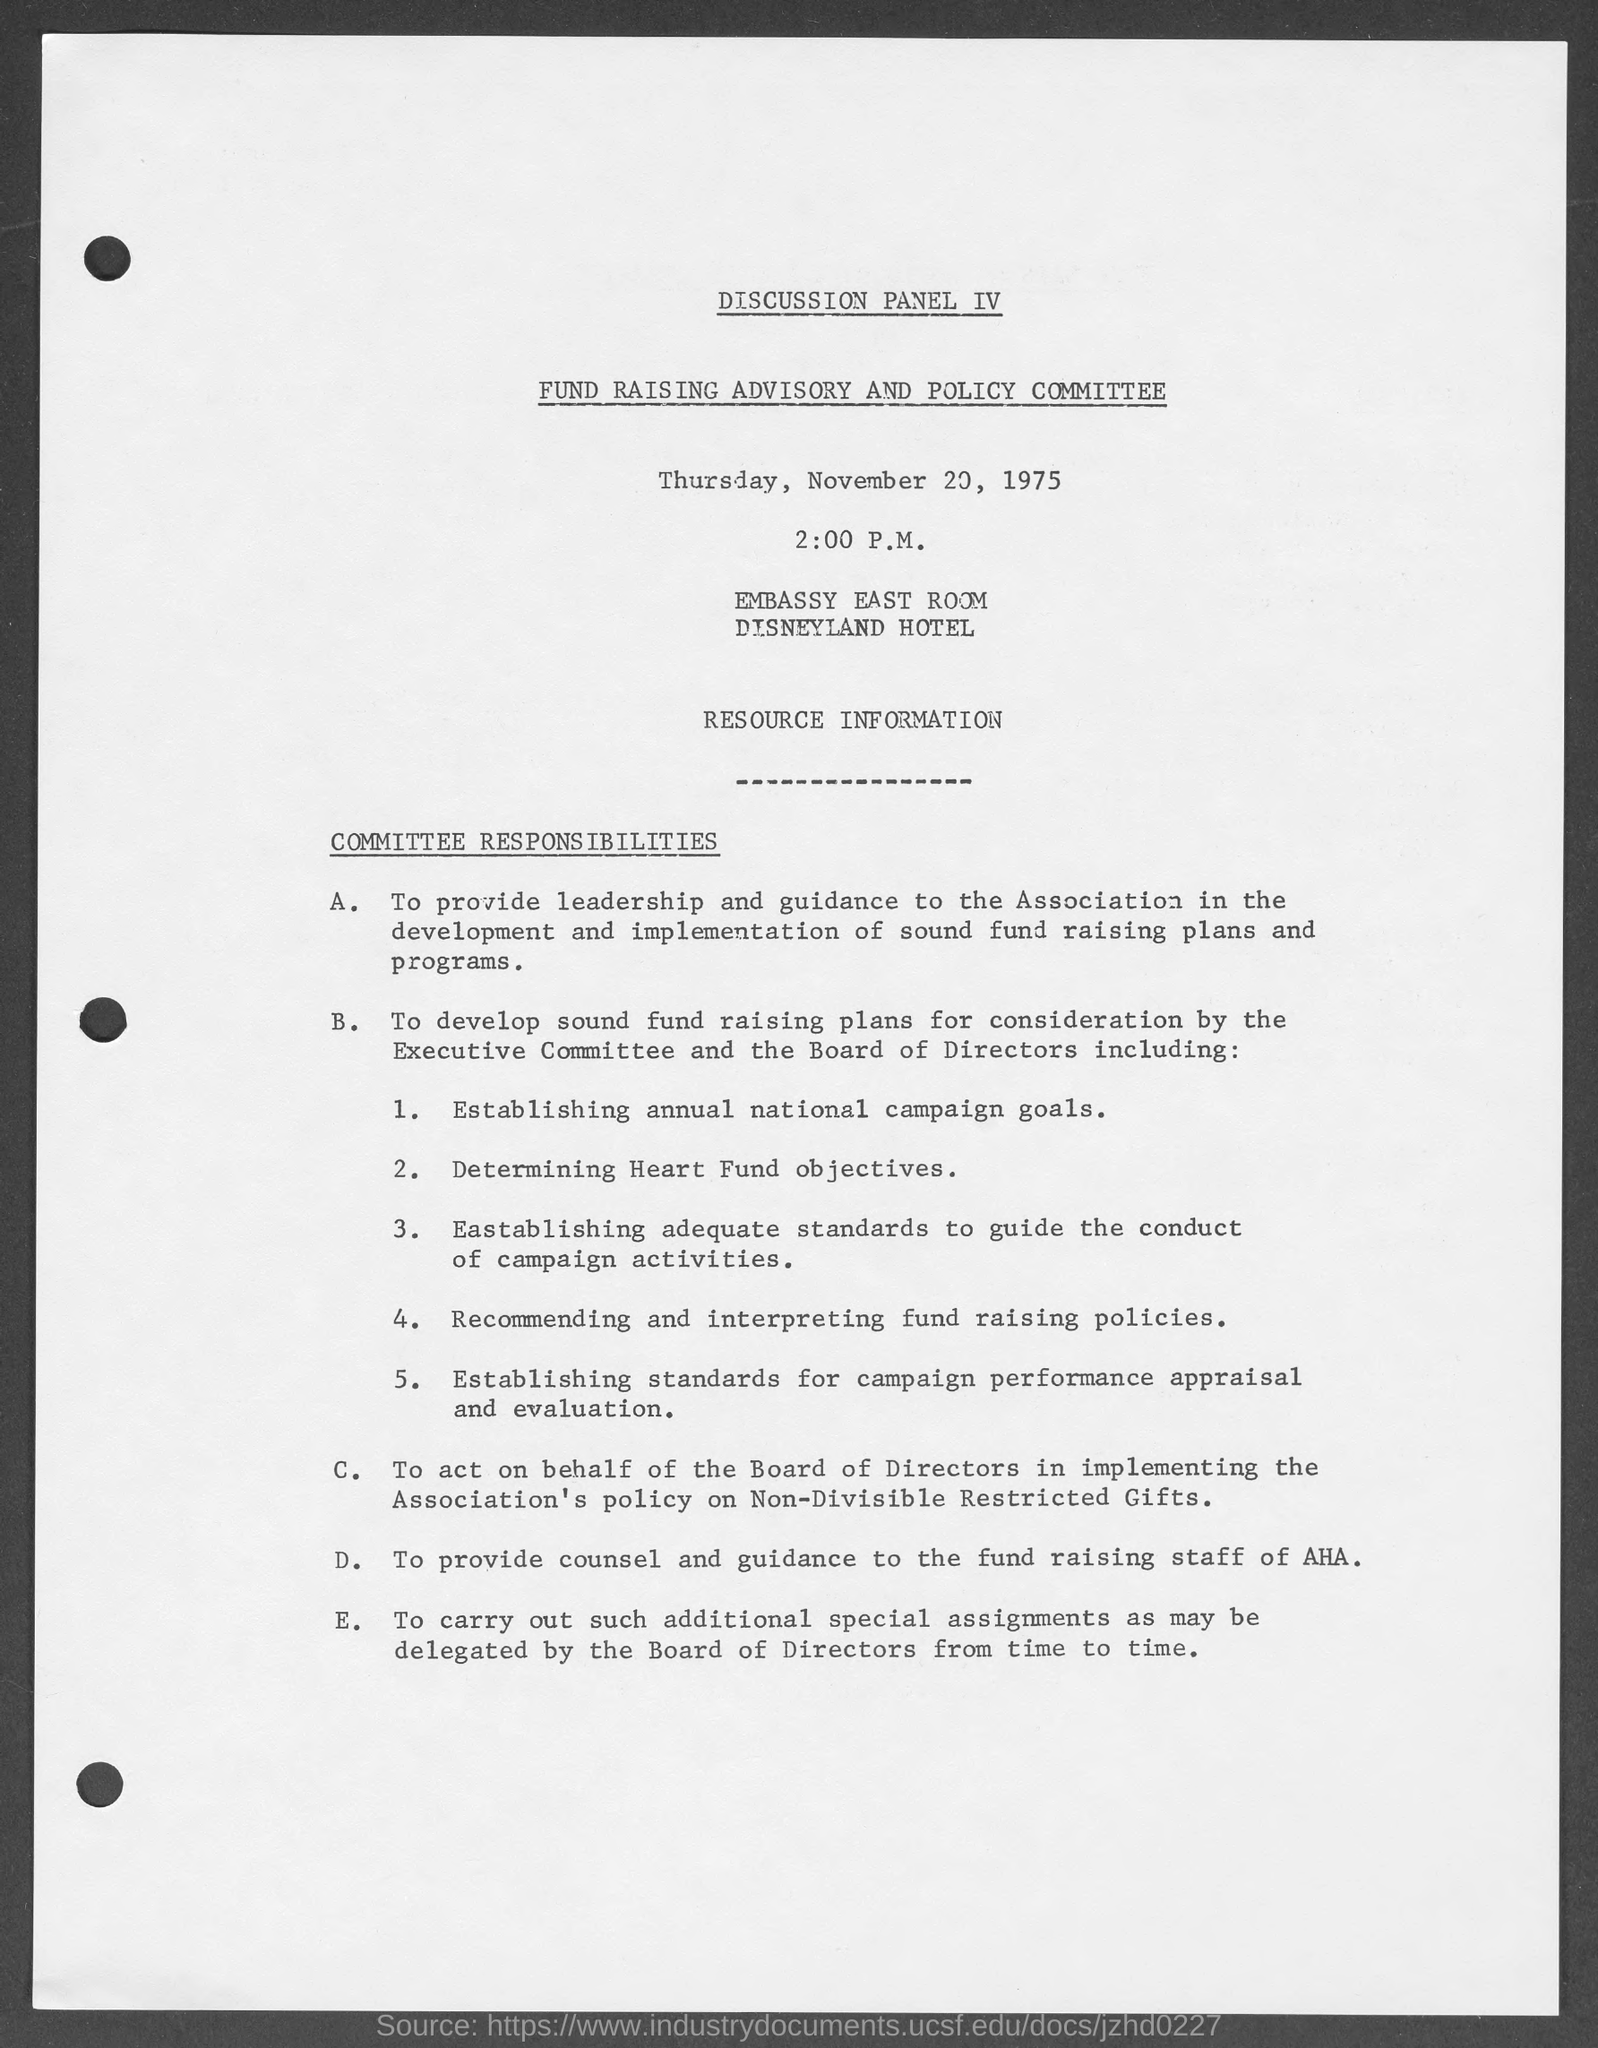What day of week is mentioned in the page?
Your response must be concise. Thursday. What is the heading of the document on top of page?
Give a very brief answer. Discussion Panel IV. What is the date mentioned in document?
Provide a short and direct response. November 20,1975. Whats the time at which this committee took place?
Your response must be concise. 2:00 P.M. 